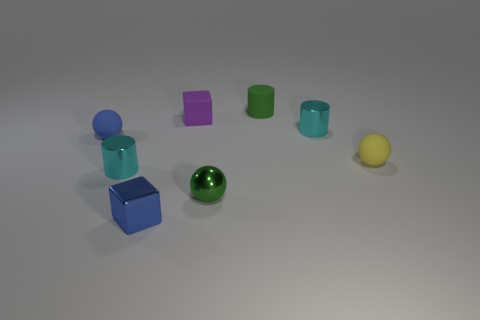Add 1 matte balls. How many objects exist? 9 Subtract all cubes. How many objects are left? 6 Add 4 cylinders. How many cylinders are left? 7 Add 2 small matte objects. How many small matte objects exist? 6 Subtract 0 gray cylinders. How many objects are left? 8 Subtract all small cylinders. Subtract all tiny blue balls. How many objects are left? 4 